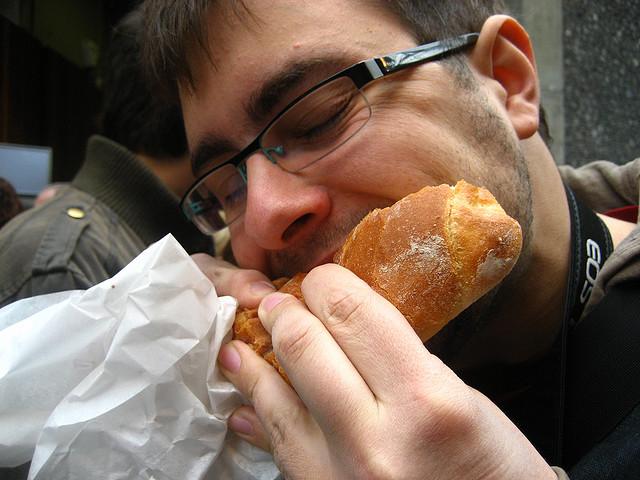Is this person obese?
Keep it brief. No. Is the person wearing glasses?
Keep it brief. Yes. No the person is not?
Give a very brief answer. Yes. 